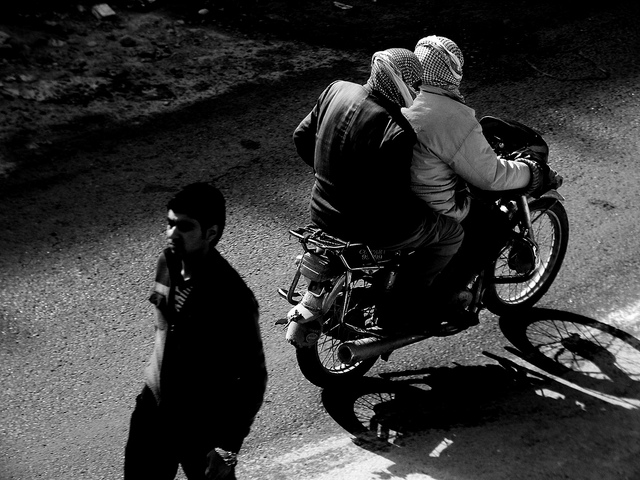What time of day does this scene appear to be captured? The shadows cast by the figures and the motorcycle suggest that this photo was taken when the sun was low in the sky, which could indicate either early morning or late afternoon. 